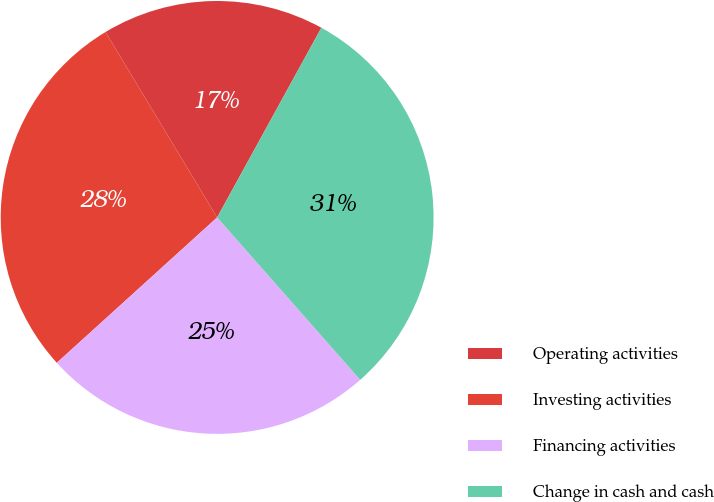Convert chart. <chart><loc_0><loc_0><loc_500><loc_500><pie_chart><fcel>Operating activities<fcel>Investing activities<fcel>Financing activities<fcel>Change in cash and cash<nl><fcel>16.62%<fcel>28.1%<fcel>24.77%<fcel>30.51%<nl></chart> 